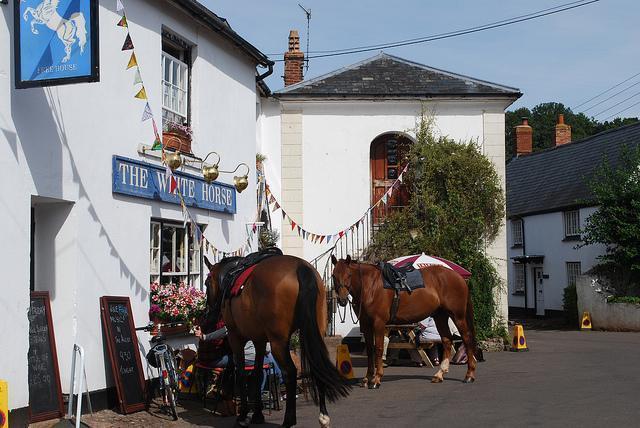What type of movie would this scene appear in?
Choose the correct response and explain in the format: 'Answer: answer
Rationale: rationale.'
Options: Mountaintop mystery, bowling documentary, western, swimming drama. Answer: western.
Rationale: There are horses. there is no bowling alley, swimming pool, or mountain. 